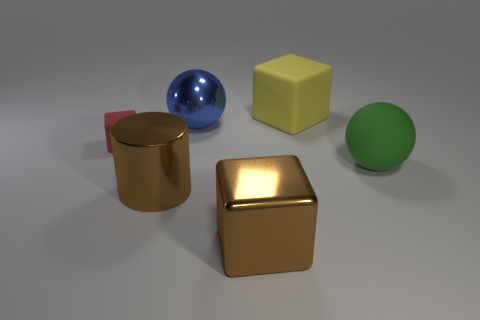Add 4 tiny rubber objects. How many objects exist? 10 Subtract all spheres. How many objects are left? 4 Add 6 big yellow cubes. How many big yellow cubes exist? 7 Subtract 1 green spheres. How many objects are left? 5 Subtract all big blue spheres. Subtract all green balls. How many objects are left? 4 Add 6 small red objects. How many small red objects are left? 7 